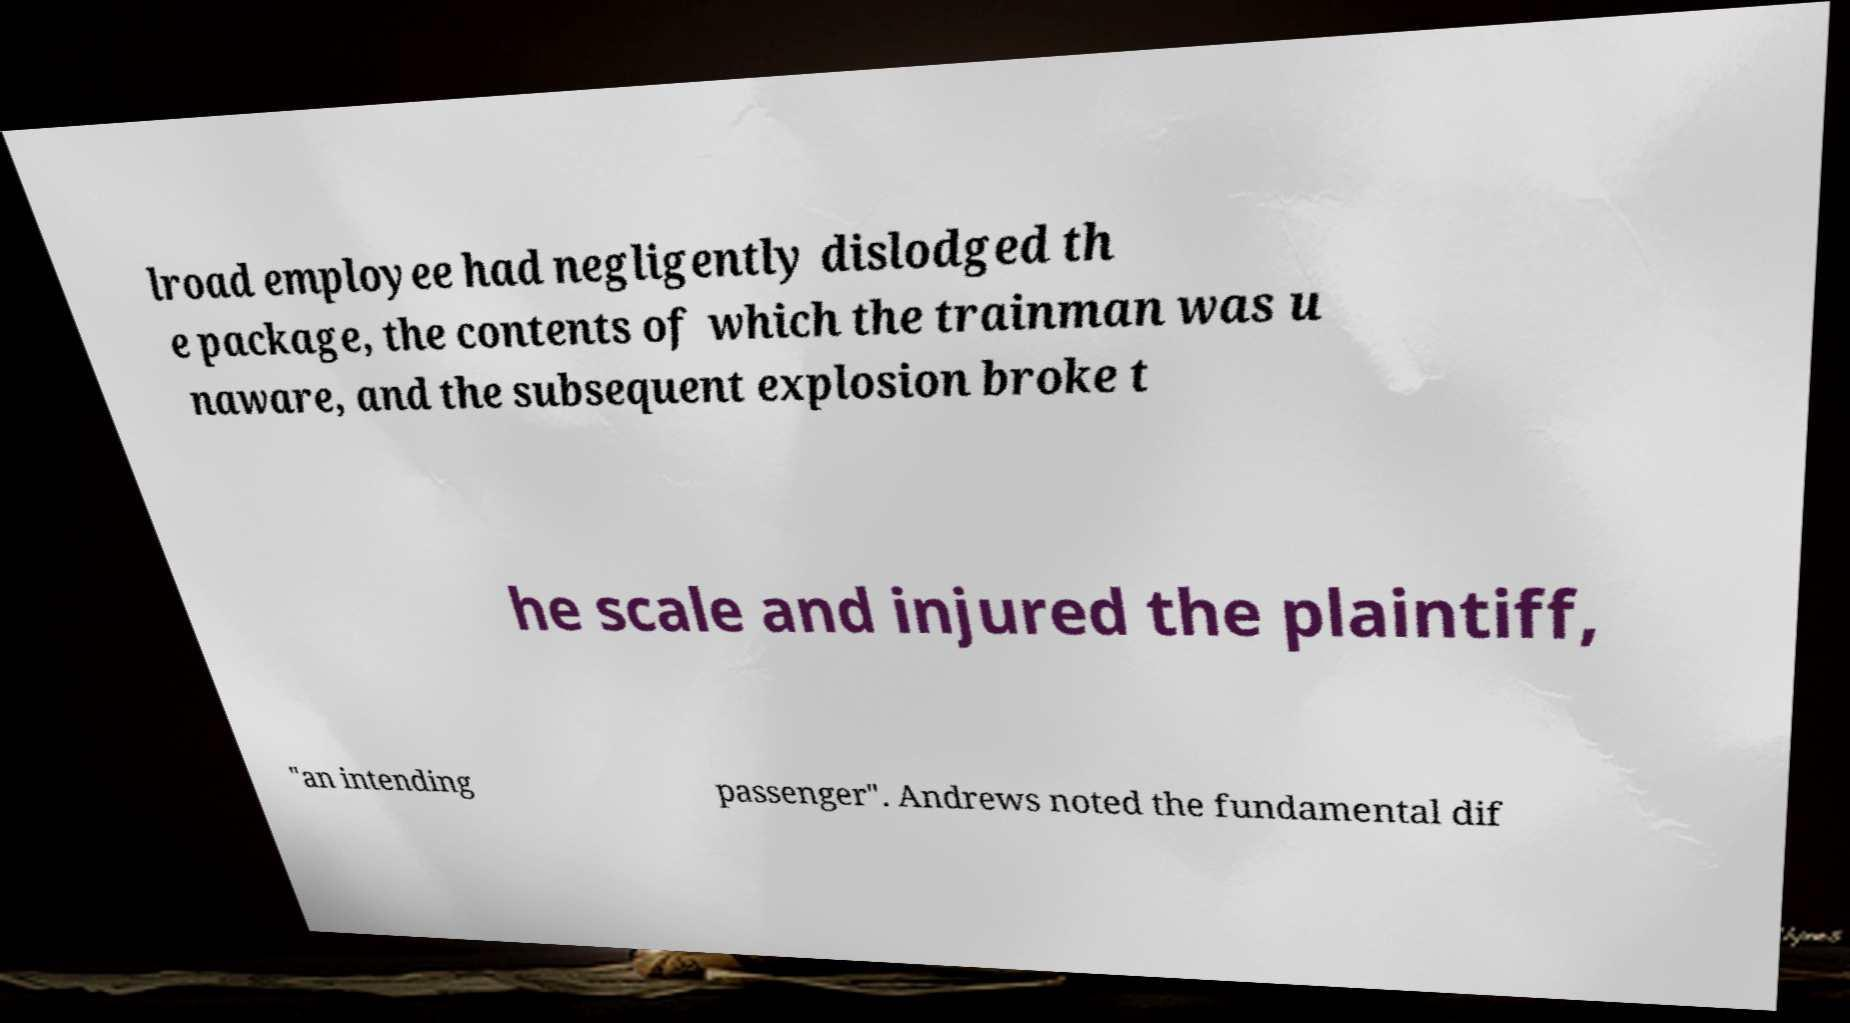For documentation purposes, I need the text within this image transcribed. Could you provide that? lroad employee had negligently dislodged th e package, the contents of which the trainman was u naware, and the subsequent explosion broke t he scale and injured the plaintiff, "an intending passenger". Andrews noted the fundamental dif 